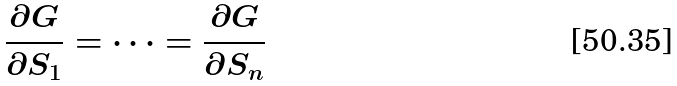<formula> <loc_0><loc_0><loc_500><loc_500>& \frac { \partial G } { \partial S _ { 1 } } = \dots = \frac { \partial G } { \partial S _ { n } }</formula> 